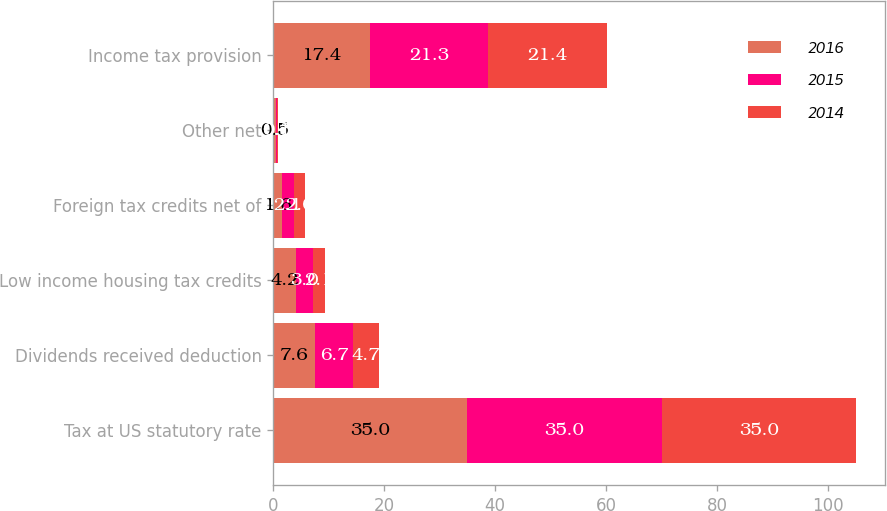Convert chart to OTSL. <chart><loc_0><loc_0><loc_500><loc_500><stacked_bar_chart><ecel><fcel>Tax at US statutory rate<fcel>Dividends received deduction<fcel>Low income housing tax credits<fcel>Foreign tax credits net of<fcel>Other net<fcel>Income tax provision<nl><fcel>2016<fcel>35<fcel>7.6<fcel>4.2<fcel>1.6<fcel>0.5<fcel>17.4<nl><fcel>2015<fcel>35<fcel>6.7<fcel>3<fcel>2.1<fcel>0.1<fcel>21.3<nl><fcel>2014<fcel>35<fcel>4.7<fcel>2.1<fcel>2<fcel>0.3<fcel>21.4<nl></chart> 